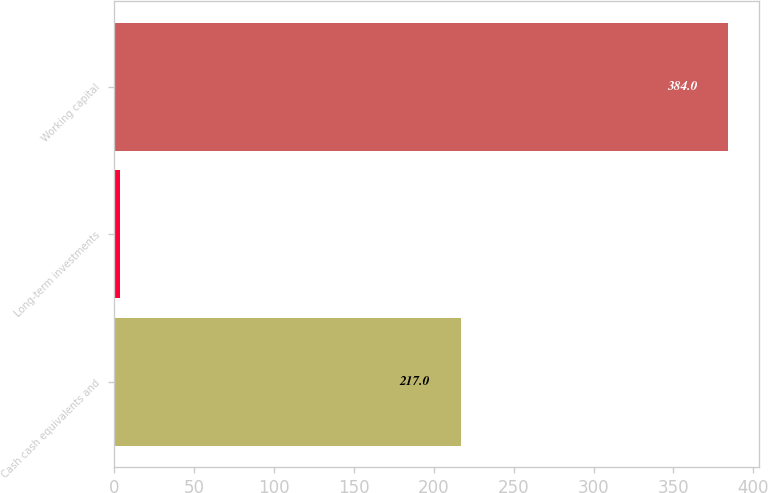Convert chart. <chart><loc_0><loc_0><loc_500><loc_500><bar_chart><fcel>Cash cash equivalents and<fcel>Long-term investments<fcel>Working capital<nl><fcel>217<fcel>4<fcel>384<nl></chart> 